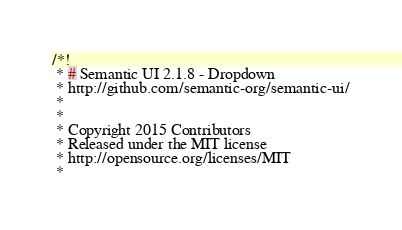Convert code to text. <code><loc_0><loc_0><loc_500><loc_500><_CSS_>/*!
 * # Semantic UI 2.1.8 - Dropdown
 * http://github.com/semantic-org/semantic-ui/
 *
 *
 * Copyright 2015 Contributors
 * Released under the MIT license
 * http://opensource.org/licenses/MIT
 *</code> 